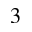Convert formula to latex. <formula><loc_0><loc_0><loc_500><loc_500>3</formula> 